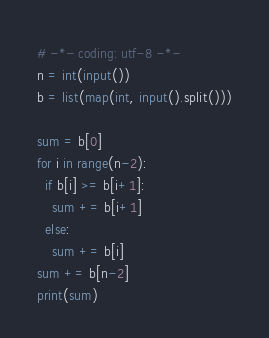Convert code to text. <code><loc_0><loc_0><loc_500><loc_500><_Python_># -*- coding: utf-8 -*-
n = int(input())
b = list(map(int, input().split()))

sum = b[0]
for i in range(n-2):
  if b[i] >= b[i+1]:
    sum += b[i+1]
  else:
    sum += b[i]
sum += b[n-2]
print(sum)</code> 